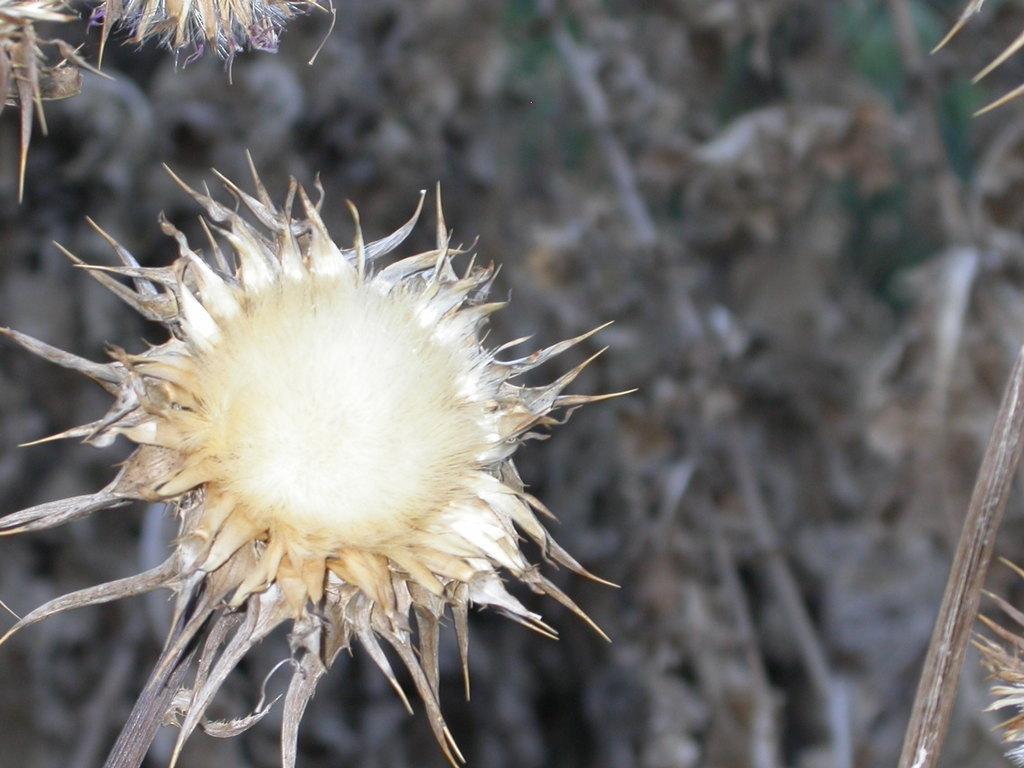In one or two sentences, can you explain what this image depicts? In the image there is a flower to the dry plant and the background of the flower is blue. 